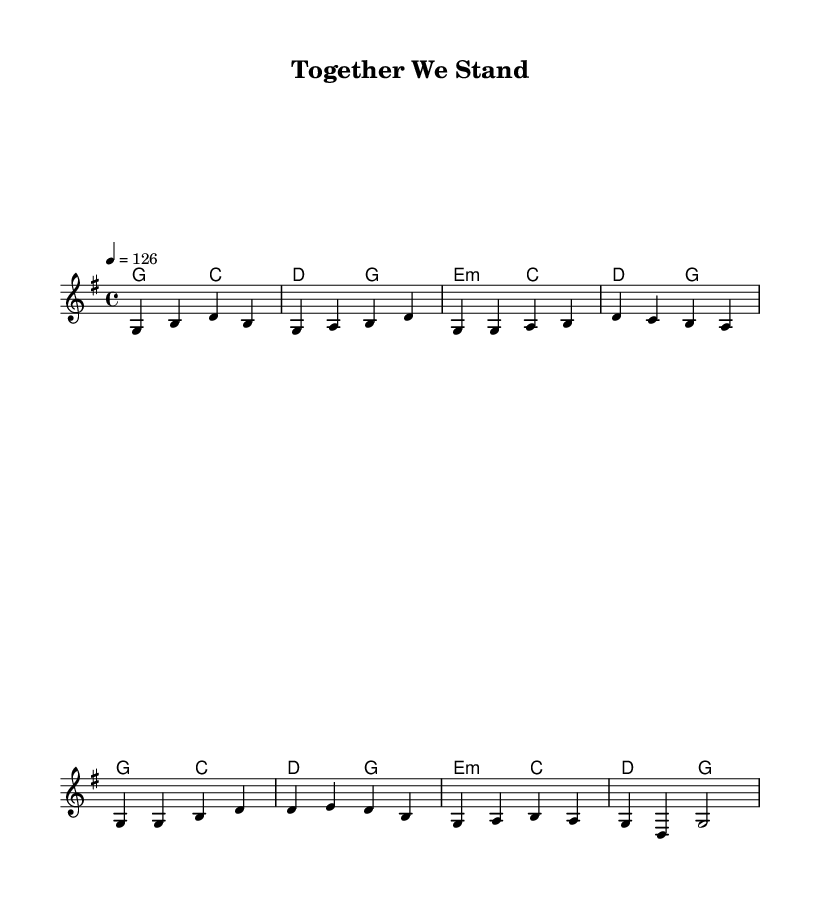What is the key signature of this music? The key signature is G major, which has one sharp (F#). This can be identified by the key signature indicated at the beginning of the staff.
Answer: G major What is the time signature of this music? The time signature is 4/4, which means there are four beats in a measure and the quarter note gets one beat. This is also noted at the beginning of the score.
Answer: 4/4 What is the tempo marking for the piece? The tempo marking is 126 beats per minute, indicated by the notation "4 = 126" under the tempo section at the beginning of the score.
Answer: 126 How many measures are there in the chorus? There are four measures in the chorus. This is found by counting the distinct groups of notes under the chorus section.
Answer: 4 What is the primary theme of the lyrics? The primary theme of the lyrics is teamwork and camaraderie, highlighting the unity and support among workers in facing challenges. This can be gathered by analyzing the verses and chorus lyrics.
Answer: Teamwork Which chord follows the first measure of the verse? The chord that follows the first measure of the verse is C major. This can be identified from the chord progression provided alongside the melody.
Answer: C major Which part of the song do the lyrics emphasize hard work and unity? The lyrics that emphasize hard work and unity are found in the chorus, as indicated by the text under the melody in that section.
Answer: Chorus 